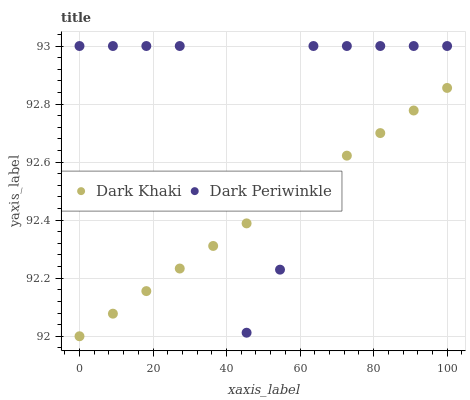Does Dark Khaki have the minimum area under the curve?
Answer yes or no. Yes. Does Dark Periwinkle have the maximum area under the curve?
Answer yes or no. Yes. Does Dark Periwinkle have the minimum area under the curve?
Answer yes or no. No. Is Dark Khaki the smoothest?
Answer yes or no. Yes. Is Dark Periwinkle the roughest?
Answer yes or no. Yes. Is Dark Periwinkle the smoothest?
Answer yes or no. No. Does Dark Khaki have the lowest value?
Answer yes or no. Yes. Does Dark Periwinkle have the lowest value?
Answer yes or no. No. Does Dark Periwinkle have the highest value?
Answer yes or no. Yes. Does Dark Periwinkle intersect Dark Khaki?
Answer yes or no. Yes. Is Dark Periwinkle less than Dark Khaki?
Answer yes or no. No. Is Dark Periwinkle greater than Dark Khaki?
Answer yes or no. No. 